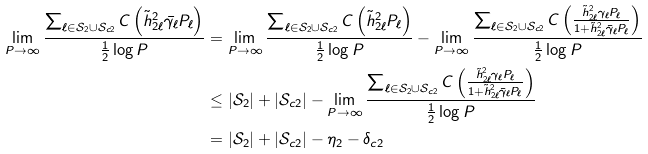<formula> <loc_0><loc_0><loc_500><loc_500>\lim _ { P \rightarrow \infty } \frac { \sum _ { \ell \in \mathcal { S } _ { 2 } \cup \mathcal { S } _ { c 2 } } C \left ( \tilde { h } _ { 2 \ell } ^ { 2 } \bar { \gamma _ { \ell } } P _ { \ell } \right ) } { \frac { 1 } { 2 } \log P } & = \lim _ { P \rightarrow \infty } \frac { \sum _ { \ell \in \mathcal { S } _ { 2 } \cup \mathcal { S } _ { c 2 } } C \left ( \tilde { h } _ { 2 \ell } ^ { 2 } P _ { \ell } \right ) } { \frac { 1 } { 2 } \log P } - \lim _ { P \rightarrow \infty } \frac { \sum _ { \ell \in \mathcal { S } _ { 2 } \cup \mathcal { S } _ { c 2 } } C \left ( \frac { \tilde { h } _ { 2 \ell } ^ { 2 } \gamma _ { \ell } P _ { \ell } } { 1 + \tilde { h } _ { 2 \ell } ^ { 2 } \bar { \gamma } _ { \ell } P _ { \ell } } \right ) } { \frac { 1 } { 2 } \log P } \\ & \leq | \mathcal { S } _ { 2 } | + | \mathcal { S } _ { c 2 } | - \lim _ { P \rightarrow \infty } \frac { \sum _ { \ell \in \mathcal { S } _ { 2 } \cup \mathcal { S } _ { c 2 } } C \left ( \frac { \tilde { h } _ { 2 \ell } ^ { 2 } \gamma _ { \ell } P _ { \ell } } { 1 + \tilde { h } _ { 2 \ell } ^ { 2 } \bar { \gamma } _ { \ell } P _ { \ell } } \right ) } { \frac { 1 } { 2 } \log P } \\ & = | \mathcal { S } _ { 2 } | + | \mathcal { S } _ { c 2 } | - \eta _ { 2 } - \delta _ { c 2 }</formula> 